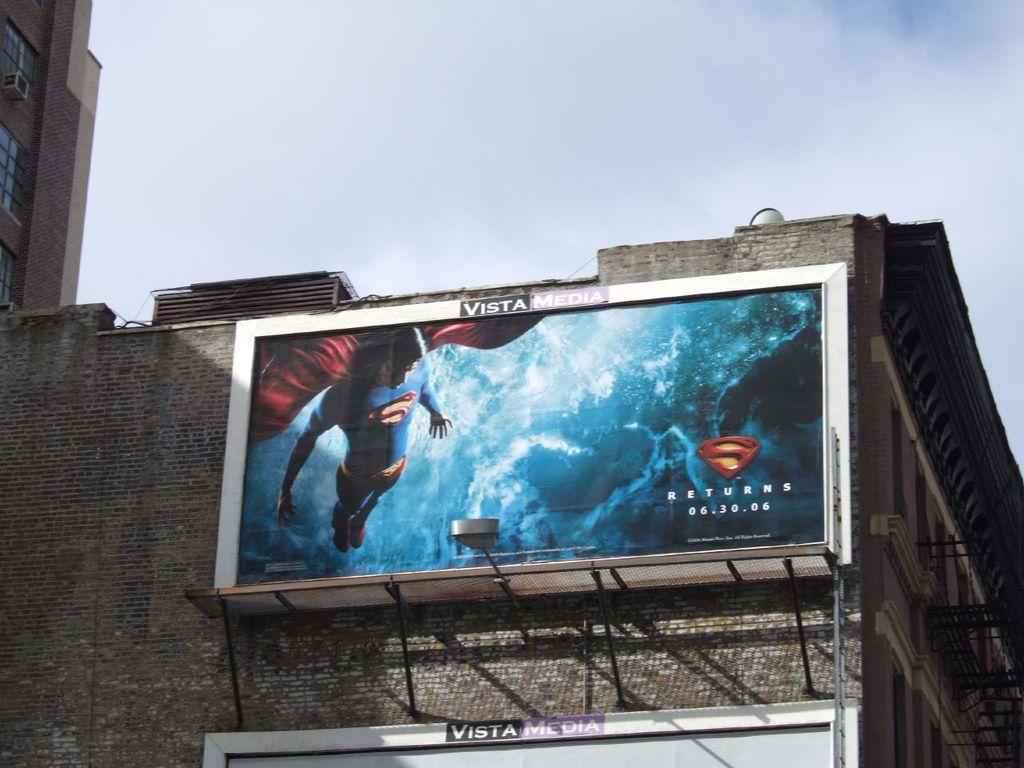What super hero is the sign advertising ?
Give a very brief answer. Superman. When does superman return according to the sign?
Keep it short and to the point. 06.30.06. 